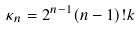<formula> <loc_0><loc_0><loc_500><loc_500>\kappa _ { n } = 2 ^ { n - 1 } ( n - 1 ) ! k</formula> 